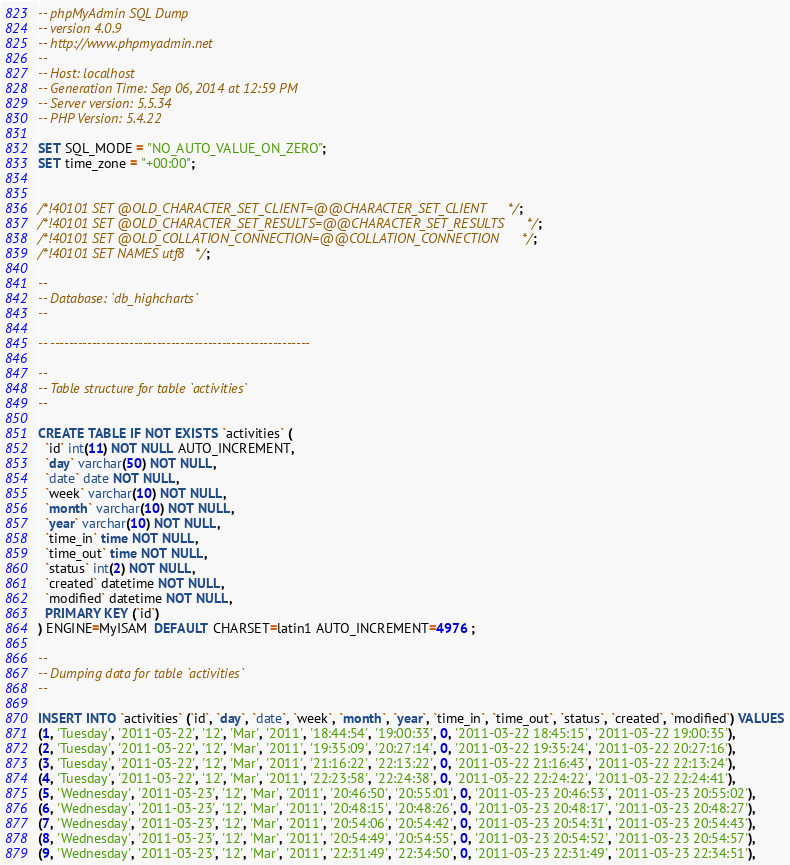<code> <loc_0><loc_0><loc_500><loc_500><_SQL_>-- phpMyAdmin SQL Dump
-- version 4.0.9
-- http://www.phpmyadmin.net
--
-- Host: localhost
-- Generation Time: Sep 06, 2014 at 12:59 PM
-- Server version: 5.5.34
-- PHP Version: 5.4.22

SET SQL_MODE = "NO_AUTO_VALUE_ON_ZERO";
SET time_zone = "+00:00";


/*!40101 SET @OLD_CHARACTER_SET_CLIENT=@@CHARACTER_SET_CLIENT */;
/*!40101 SET @OLD_CHARACTER_SET_RESULTS=@@CHARACTER_SET_RESULTS */;
/*!40101 SET @OLD_COLLATION_CONNECTION=@@COLLATION_CONNECTION */;
/*!40101 SET NAMES utf8 */;

--
-- Database: `db_highcharts`
--

-- --------------------------------------------------------

--
-- Table structure for table `activities`
--

CREATE TABLE IF NOT EXISTS `activities` (
  `id` int(11) NOT NULL AUTO_INCREMENT,
  `day` varchar(50) NOT NULL,
  `date` date NOT NULL,
  `week` varchar(10) NOT NULL,
  `month` varchar(10) NOT NULL,
  `year` varchar(10) NOT NULL,
  `time_in` time NOT NULL,
  `time_out` time NOT NULL,
  `status` int(2) NOT NULL,
  `created` datetime NOT NULL,
  `modified` datetime NOT NULL,
  PRIMARY KEY (`id`)
) ENGINE=MyISAM  DEFAULT CHARSET=latin1 AUTO_INCREMENT=4976 ;

--
-- Dumping data for table `activities`
--

INSERT INTO `activities` (`id`, `day`, `date`, `week`, `month`, `year`, `time_in`, `time_out`, `status`, `created`, `modified`) VALUES
(1, 'Tuesday', '2011-03-22', '12', 'Mar', '2011', '18:44:54', '19:00:33', 0, '2011-03-22 18:45:15', '2011-03-22 19:00:35'),
(2, 'Tuesday', '2011-03-22', '12', 'Mar', '2011', '19:35:09', '20:27:14', 0, '2011-03-22 19:35:24', '2011-03-22 20:27:16'),
(3, 'Tuesday', '2011-03-22', '12', 'Mar', '2011', '21:16:22', '22:13:22', 0, '2011-03-22 21:16:43', '2011-03-22 22:13:24'),
(4, 'Tuesday', '2011-03-22', '12', 'Mar', '2011', '22:23:58', '22:24:38', 0, '2011-03-22 22:24:22', '2011-03-22 22:24:41'),
(5, 'Wednesday', '2011-03-23', '12', 'Mar', '2011', '20:46:50', '20:55:01', 0, '2011-03-23 20:46:53', '2011-03-23 20:55:02'),
(6, 'Wednesday', '2011-03-23', '12', 'Mar', '2011', '20:48:15', '20:48:26', 0, '2011-03-23 20:48:17', '2011-03-23 20:48:27'),
(7, 'Wednesday', '2011-03-23', '12', 'Mar', '2011', '20:54:06', '20:54:42', 0, '2011-03-23 20:54:31', '2011-03-23 20:54:43'),
(8, 'Wednesday', '2011-03-23', '12', 'Mar', '2011', '20:54:49', '20:54:55', 0, '2011-03-23 20:54:52', '2011-03-23 20:54:57'),
(9, 'Wednesday', '2011-03-23', '12', 'Mar', '2011', '22:31:49', '22:34:50', 0, '2011-03-23 22:31:49', '2011-03-23 22:34:51'),</code> 